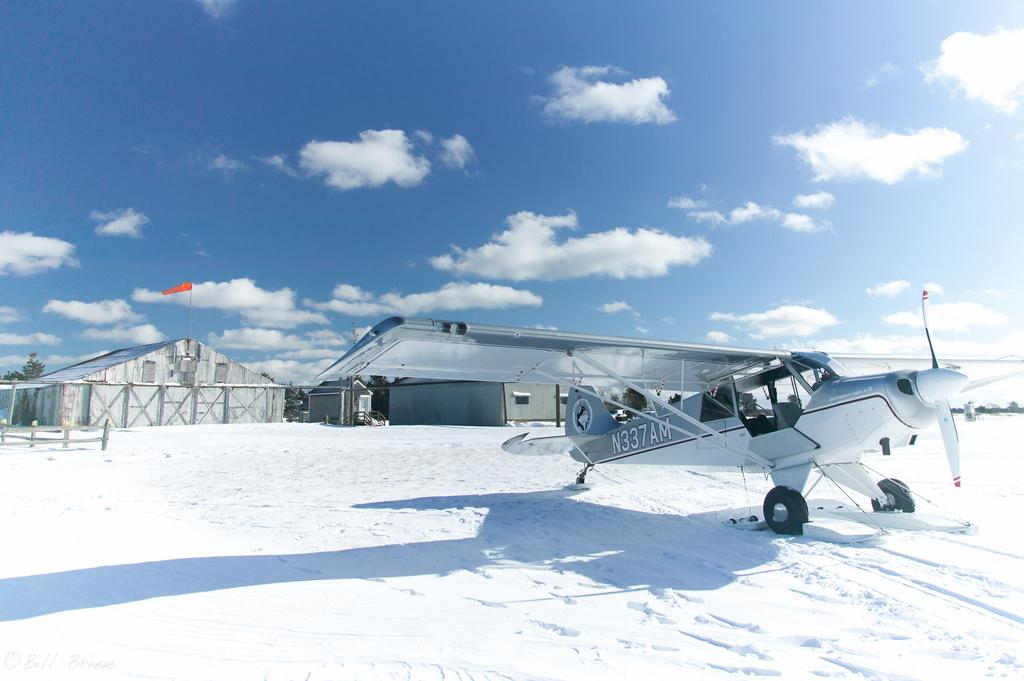<image>
Write a terse but informative summary of the picture. A plane with call number N337AM sits on a snowy field in front of some buildings. 